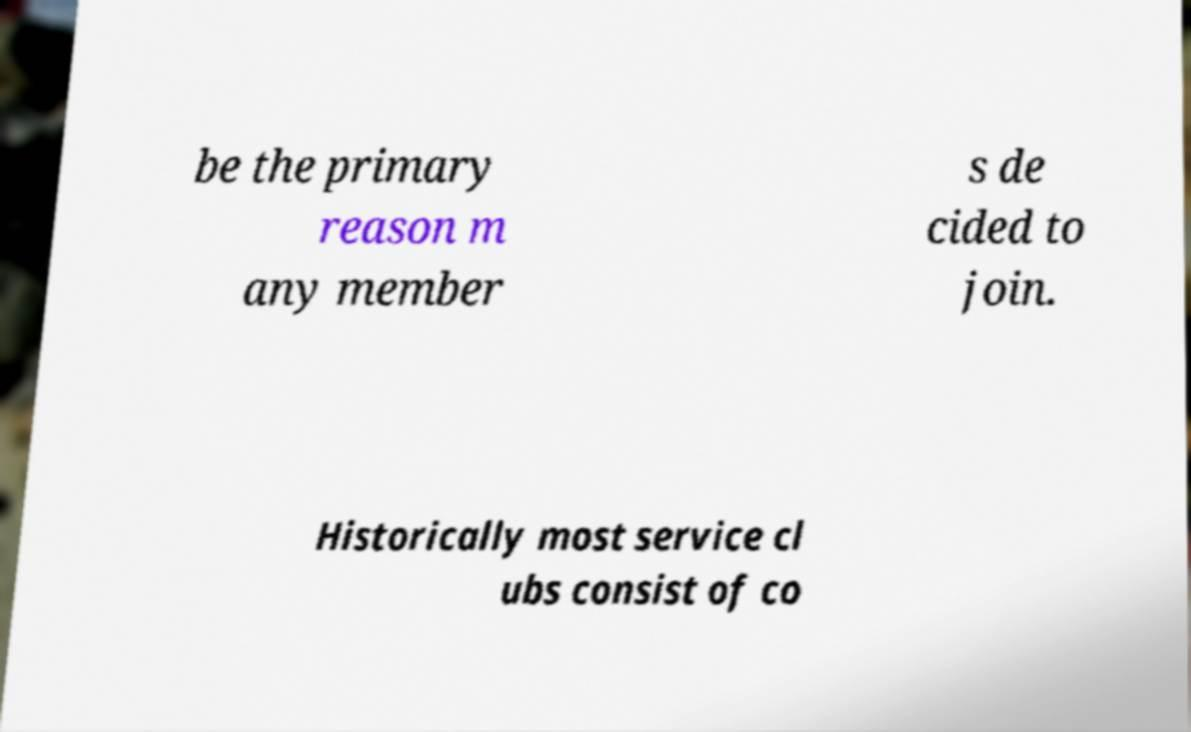What messages or text are displayed in this image? I need them in a readable, typed format. be the primary reason m any member s de cided to join. Historically most service cl ubs consist of co 